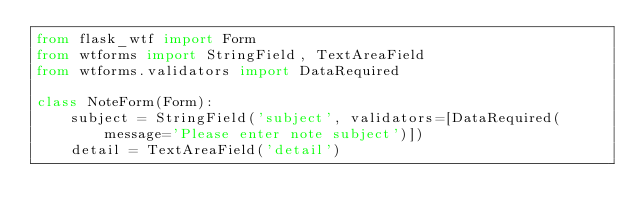<code> <loc_0><loc_0><loc_500><loc_500><_Python_>from flask_wtf import Form
from wtforms import StringField, TextAreaField
from wtforms.validators import DataRequired

class NoteForm(Form):
    subject = StringField('subject', validators=[DataRequired(message='Please enter note subject')])
    detail = TextAreaField('detail')
</code> 